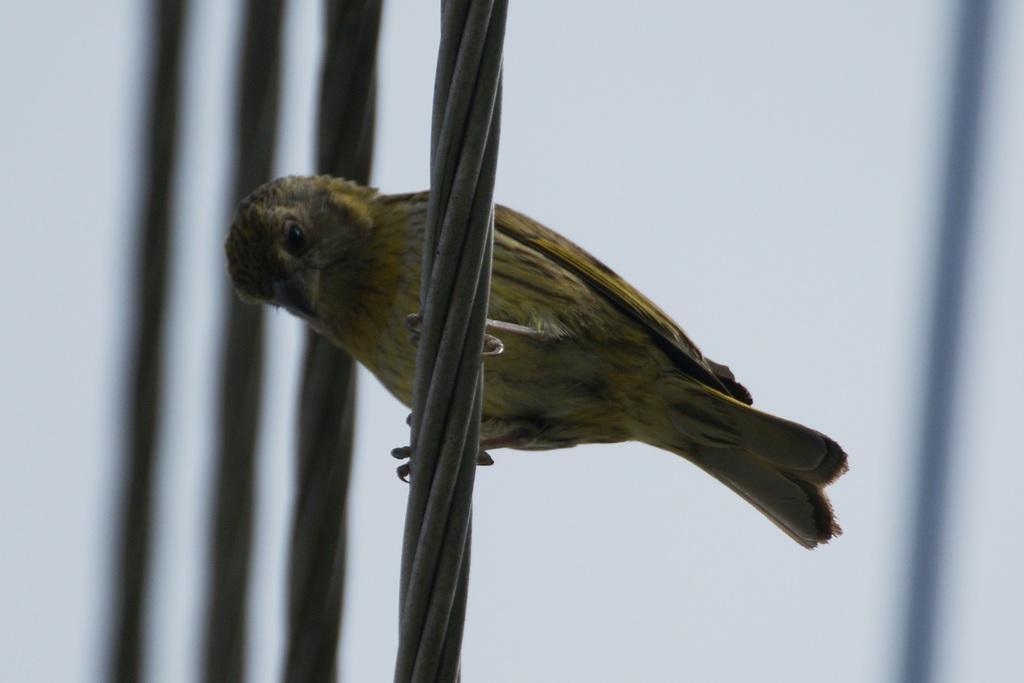What type of animal is present in the image? There is a bird in the image. Where is the bird located in the image? The bird is standing on a cable. What grade does the bird receive for its performance in the committee meeting? There is no committee meeting or grade mentioned in the image, as it only features a bird standing on a cable. 